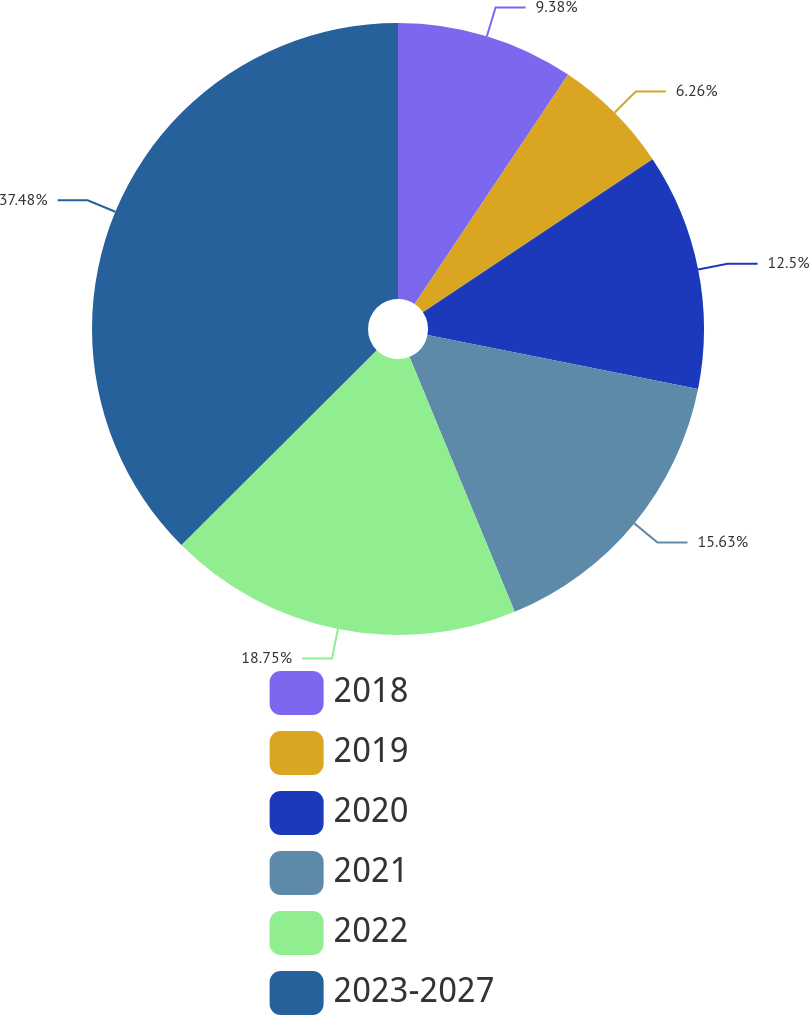Convert chart to OTSL. <chart><loc_0><loc_0><loc_500><loc_500><pie_chart><fcel>2018<fcel>2019<fcel>2020<fcel>2021<fcel>2022<fcel>2023-2027<nl><fcel>9.38%<fcel>6.26%<fcel>12.5%<fcel>15.63%<fcel>18.75%<fcel>37.48%<nl></chart> 